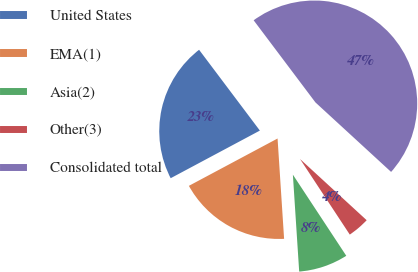Convert chart. <chart><loc_0><loc_0><loc_500><loc_500><pie_chart><fcel>United States<fcel>EMA(1)<fcel>Asia(2)<fcel>Other(3)<fcel>Consolidated total<nl><fcel>22.54%<fcel>18.23%<fcel>8.23%<fcel>3.91%<fcel>47.09%<nl></chart> 